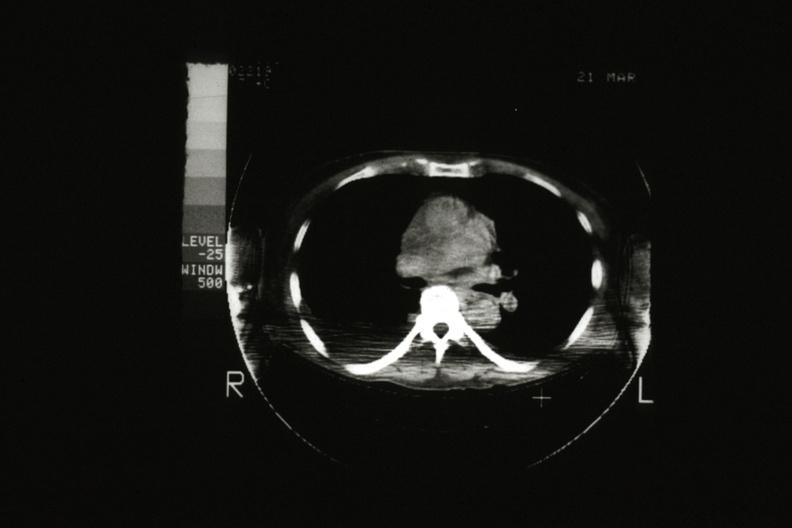what does cat scan?
Answer the question using a single word or phrase. Showing tumor mass invading superior vena ca 